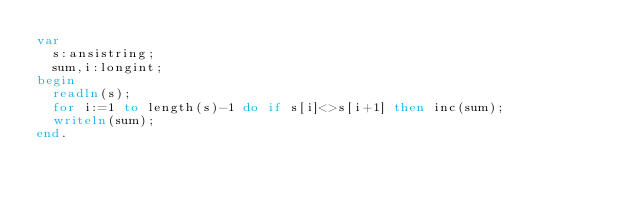<code> <loc_0><loc_0><loc_500><loc_500><_Pascal_>var
  s:ansistring;
  sum,i:longint;
begin
  readln(s);
  for i:=1 to length(s)-1 do if s[i]<>s[i+1] then inc(sum);
  writeln(sum);
end.</code> 